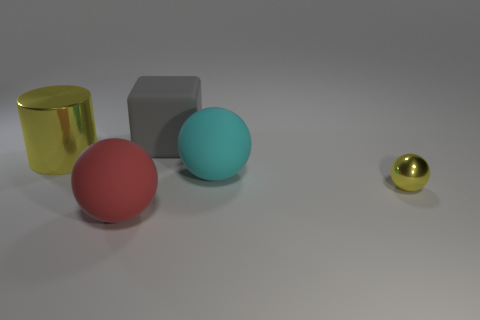Subtract all rubber balls. How many balls are left? 1 Add 1 large shiny objects. How many objects exist? 6 Subtract 3 balls. How many balls are left? 0 Subtract all yellow spheres. How many spheres are left? 2 Subtract all red cylinders. How many red cubes are left? 0 Add 5 big cyan balls. How many big cyan balls exist? 6 Subtract 0 green balls. How many objects are left? 5 Subtract all cylinders. How many objects are left? 4 Subtract all purple spheres. Subtract all purple cylinders. How many spheres are left? 3 Subtract all gray rubber things. Subtract all cyan things. How many objects are left? 3 